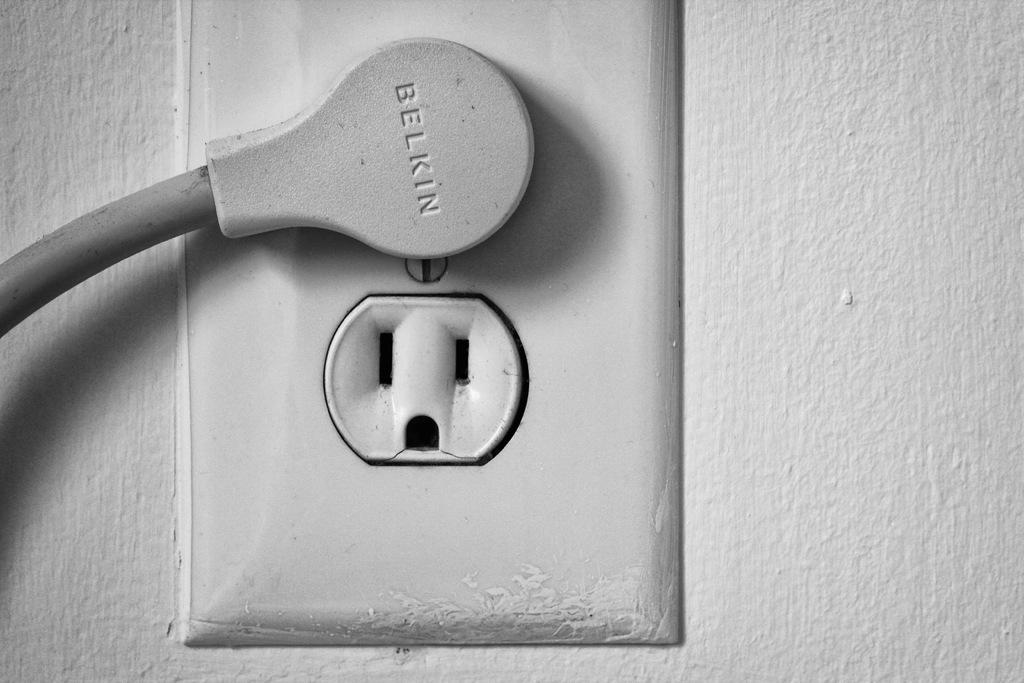<image>
Summarize the visual content of the image. A gray Belkin plug is connected to a wall socket. 